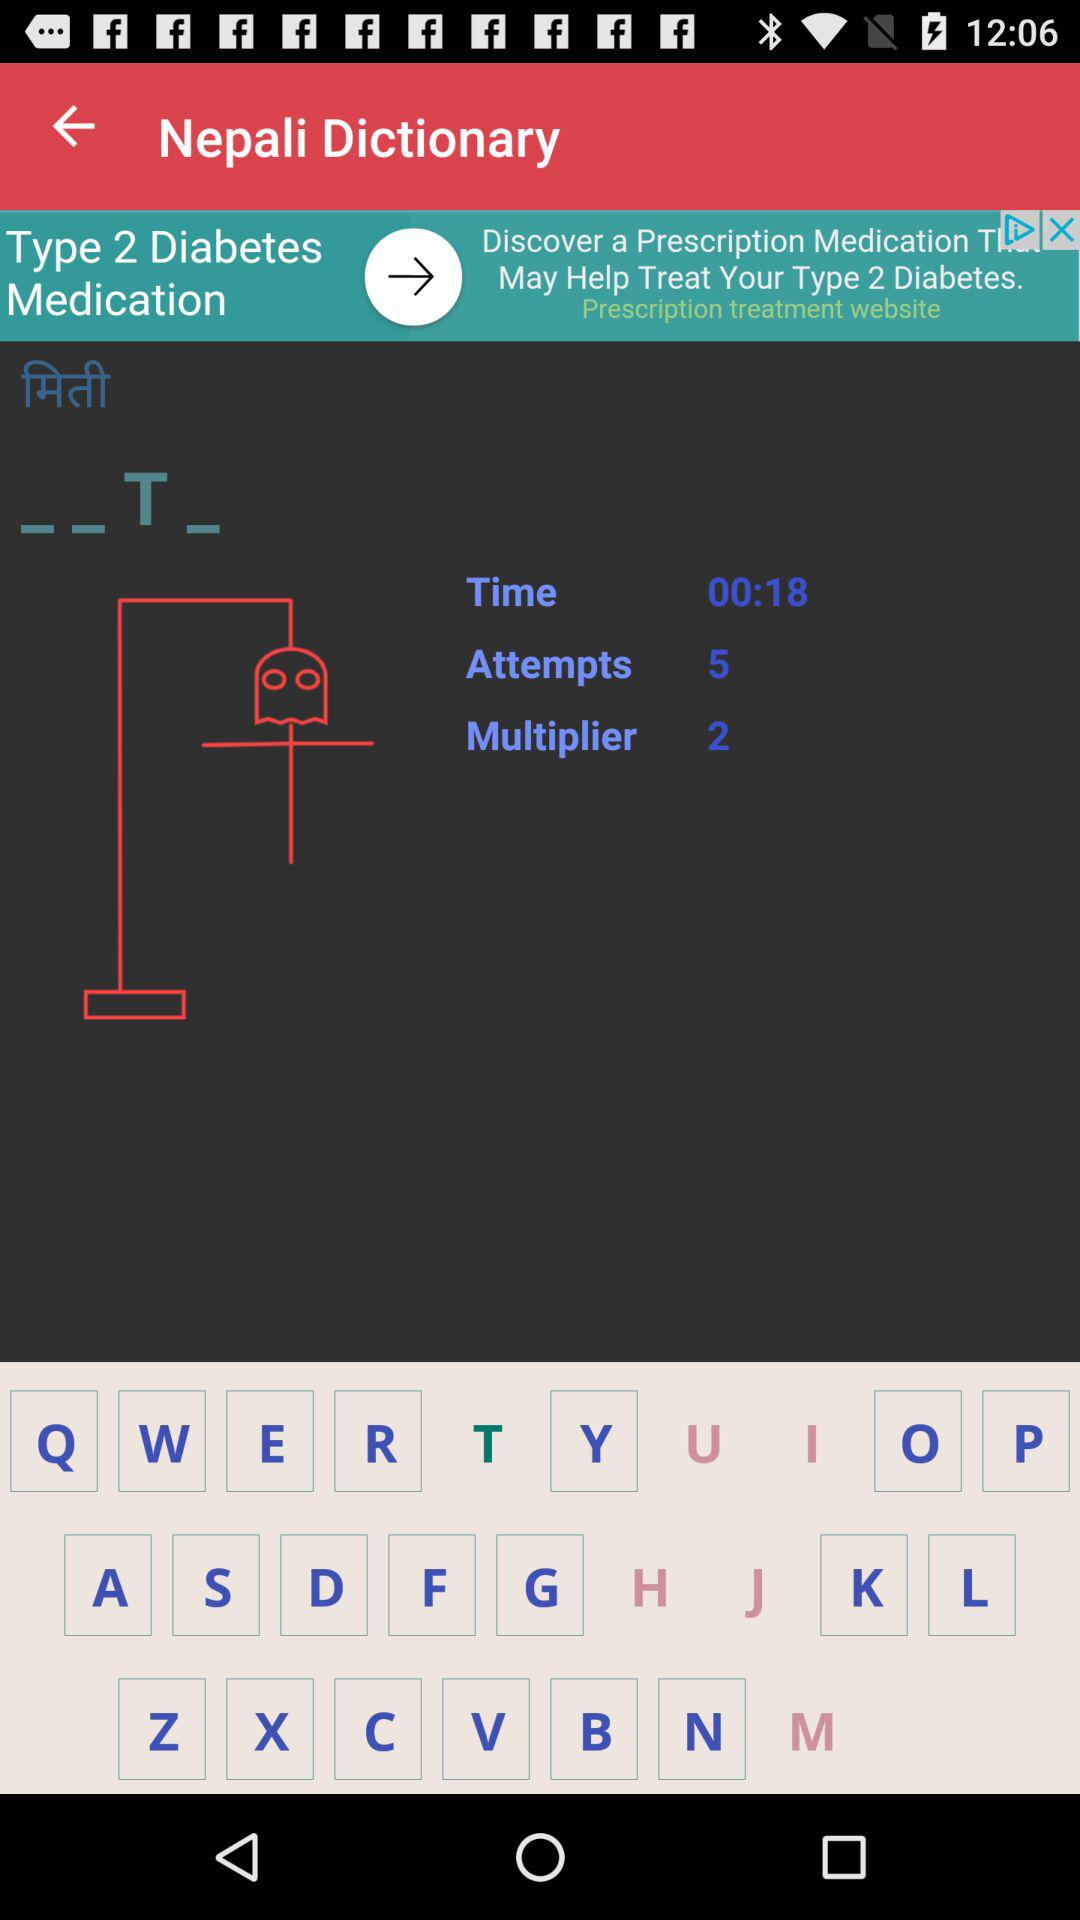How many more multiplier points do I need to get to 3?
Answer the question using a single word or phrase. 1 